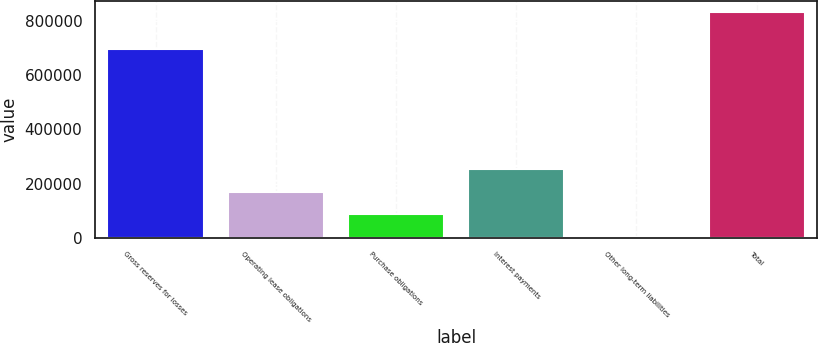Convert chart. <chart><loc_0><loc_0><loc_500><loc_500><bar_chart><fcel>Gross reserves for losses<fcel>Operating lease obligations<fcel>Purchase obligations<fcel>Interest payments<fcel>Other long-term liabilities<fcel>Total<nl><fcel>694929<fcel>169463<fcel>86534.1<fcel>252392<fcel>3605<fcel>832896<nl></chart> 